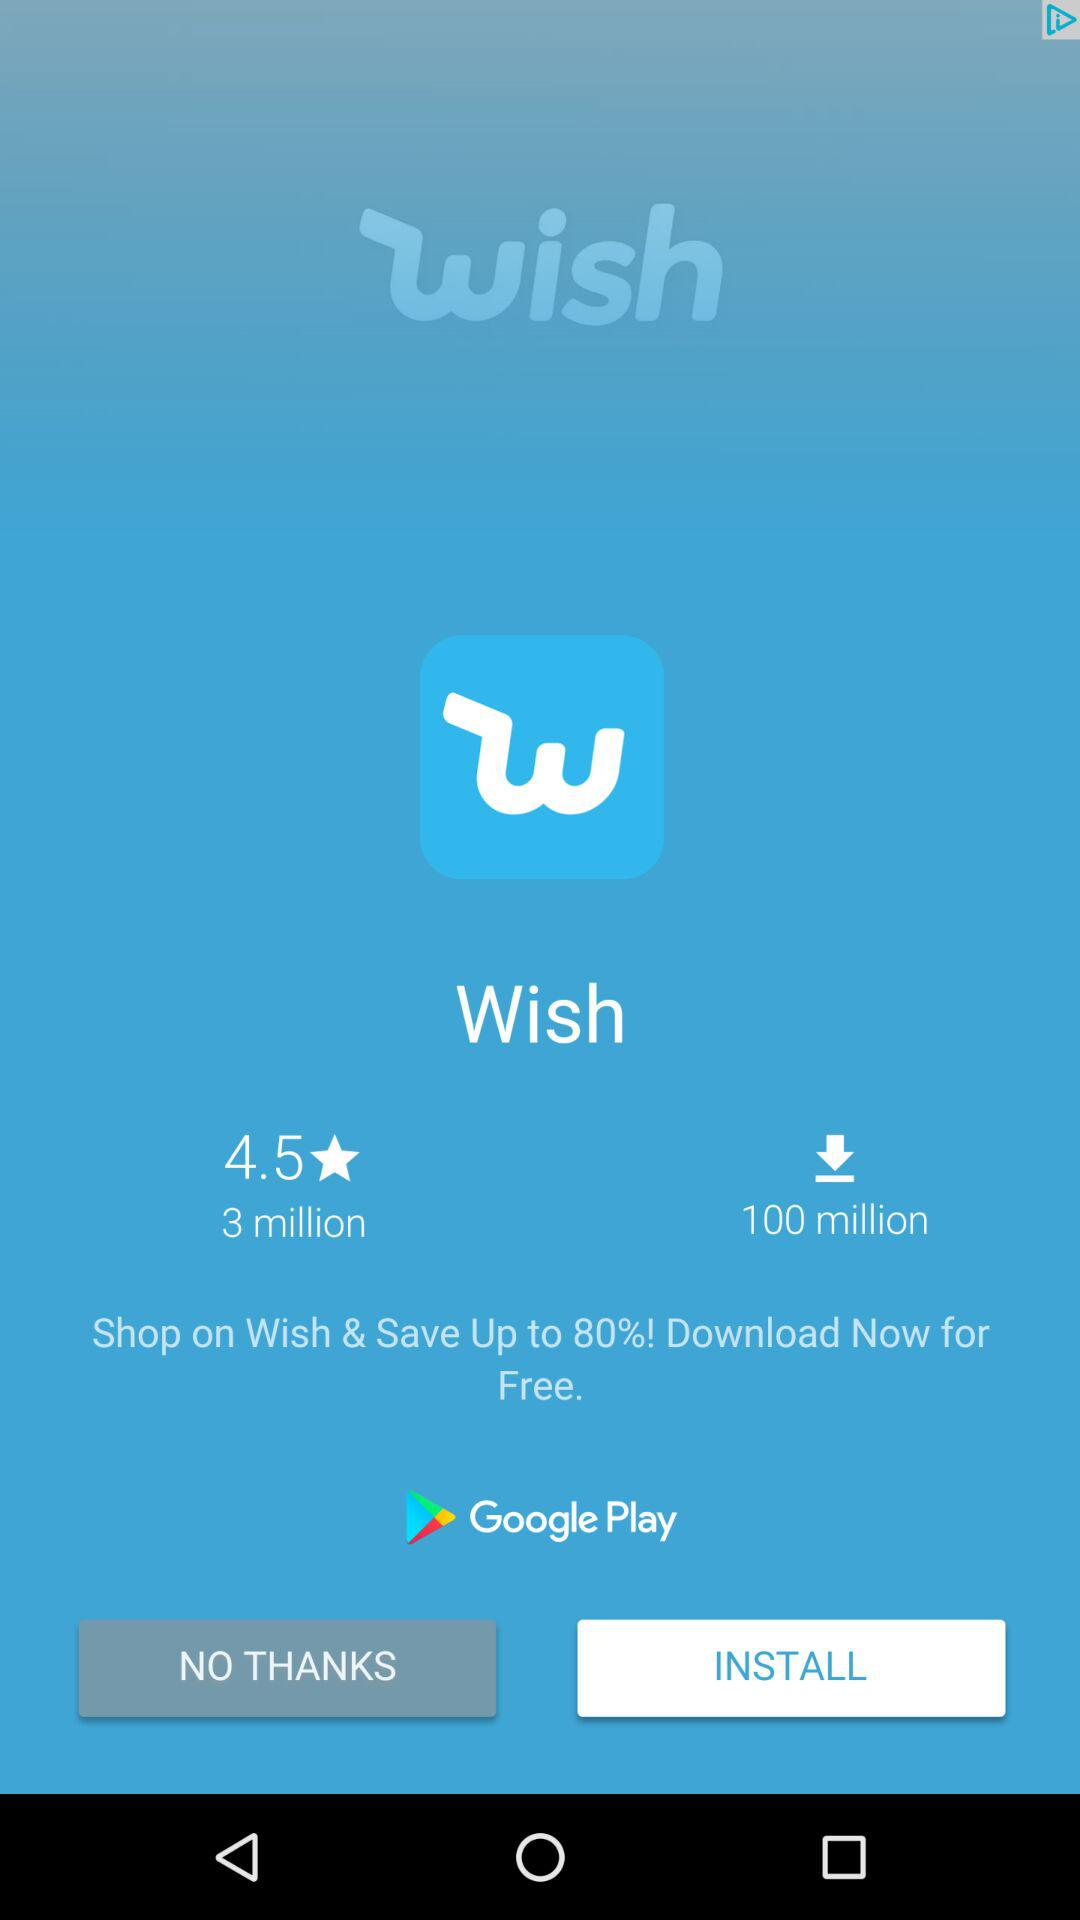How many more downloads does Wish have than ratings?
Answer the question using a single word or phrase. 97 million 